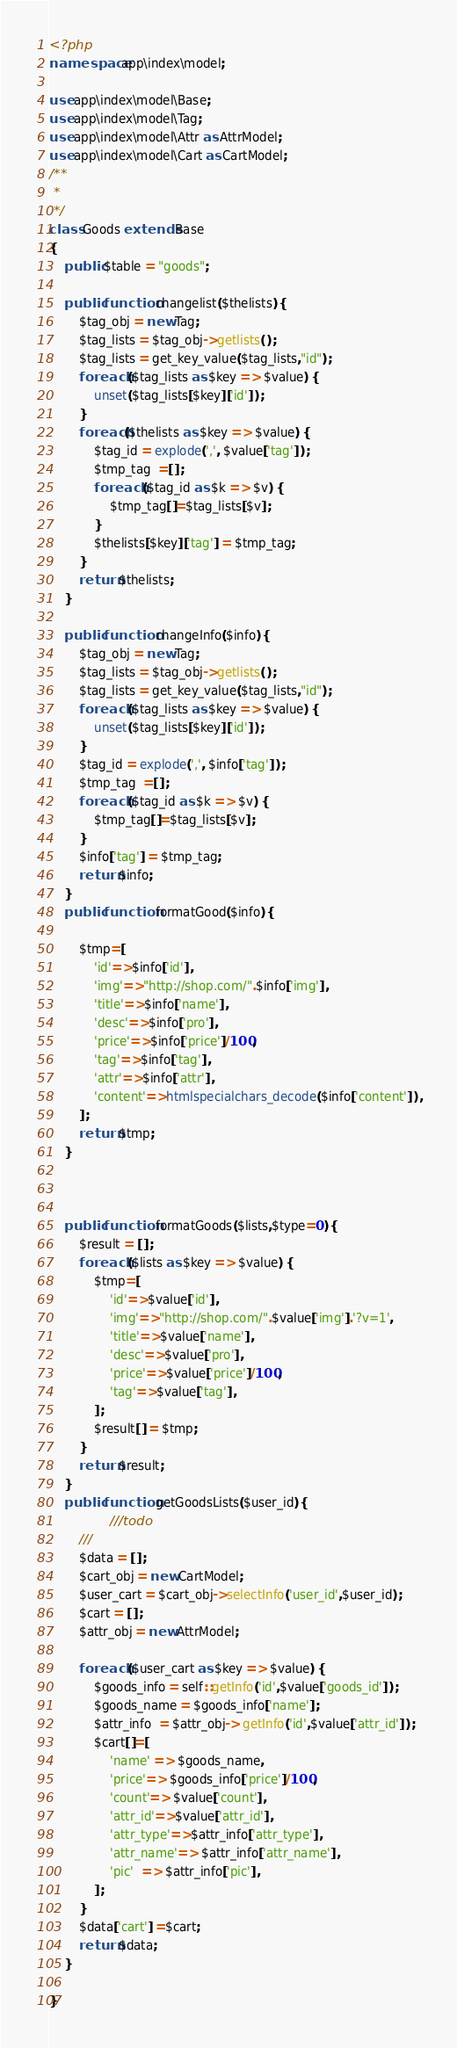<code> <loc_0><loc_0><loc_500><loc_500><_PHP_><?php
namespace app\index\model;

use app\index\model\Base;
use app\index\model\Tag;
use app\index\model\Attr as AttrModel;
use app\index\model\Cart as CartModel;
/**
 * 
 */
class Goods extends Base
{
    public $table = "goods";

    public function changelist($thelists){
        $tag_obj = new Tag;
        $tag_lists = $tag_obj->getlists();
        $tag_lists = get_key_value($tag_lists,"id");
        foreach ($tag_lists as $key => $value) {
            unset($tag_lists[$key]['id']);
        }
        foreach($thelists as $key => $value) {
            $tag_id = explode(',', $value['tag']);
            $tmp_tag  =[];
            foreach ($tag_id as $k => $v) {
                $tmp_tag[]=$tag_lists[$v];
            }
            $thelists[$key]['tag'] = $tmp_tag;
        }
        return $thelists;
    }

    public function changeInfo($info){
        $tag_obj = new Tag;
        $tag_lists = $tag_obj->getlists();
        $tag_lists = get_key_value($tag_lists,"id");
        foreach ($tag_lists as $key => $value) {
            unset($tag_lists[$key]['id']);
        }
        $tag_id = explode(',', $info['tag']);
        $tmp_tag  =[];
        foreach ($tag_id as $k => $v) {
            $tmp_tag[]=$tag_lists[$v];
        }
        $info['tag'] = $tmp_tag;
        return $info;        
    }
    public function formatGood($info){
        
        $tmp=[
            'id'=>$info['id'],
            'img'=>"http://shop.com/".$info['img'],
            'title'=>$info['name'],
            'desc'=>$info['pro'],
            'price'=>$info['price']/100,
            'tag'=>$info['tag'],
            'attr'=>$info['attr'],
            'content'=>htmlspecialchars_decode($info['content']),
        ];
        return $tmp;
    }



    public function formatGoods($lists,$type=0){
        $result = [];
        foreach ($lists as $key => $value) {
            $tmp=[
                'id'=>$value['id'],
                'img'=>"http://shop.com/".$value['img'].'?v=1',
                'title'=>$value['name'],
                'desc'=>$value['pro'],
                'price'=>$value['price']/100,
                'tag'=>$value['tag'],
            ];
            $result[] = $tmp;
        }
        return $result;
    }
    public function getGoodsLists($user_id){
                ///todo
        ///
        $data = [];
        $cart_obj = new CartModel;
        $user_cart = $cart_obj->selectInfo('user_id',$user_id);
        $cart = [];
        $attr_obj = new AttrModel;

        foreach ($user_cart as $key => $value) {
            $goods_info = self::getInfo('id',$value['goods_id']);
            $goods_name = $goods_info['name'];
            $attr_info  = $attr_obj-> getInfo('id',$value['attr_id']);
            $cart[]=[
                'name' => $goods_name,
                'price'=> $goods_info['price']/100,
                'count'=> $value['count'],
                'attr_id'=>$value['attr_id'],
                'attr_type'=>$attr_info['attr_type'],
                'attr_name'=> $attr_info['attr_name'],
                'pic'  => $attr_info['pic'],
            ];
        }
        $data['cart'] =$cart;
        return $data;
    }

}</code> 